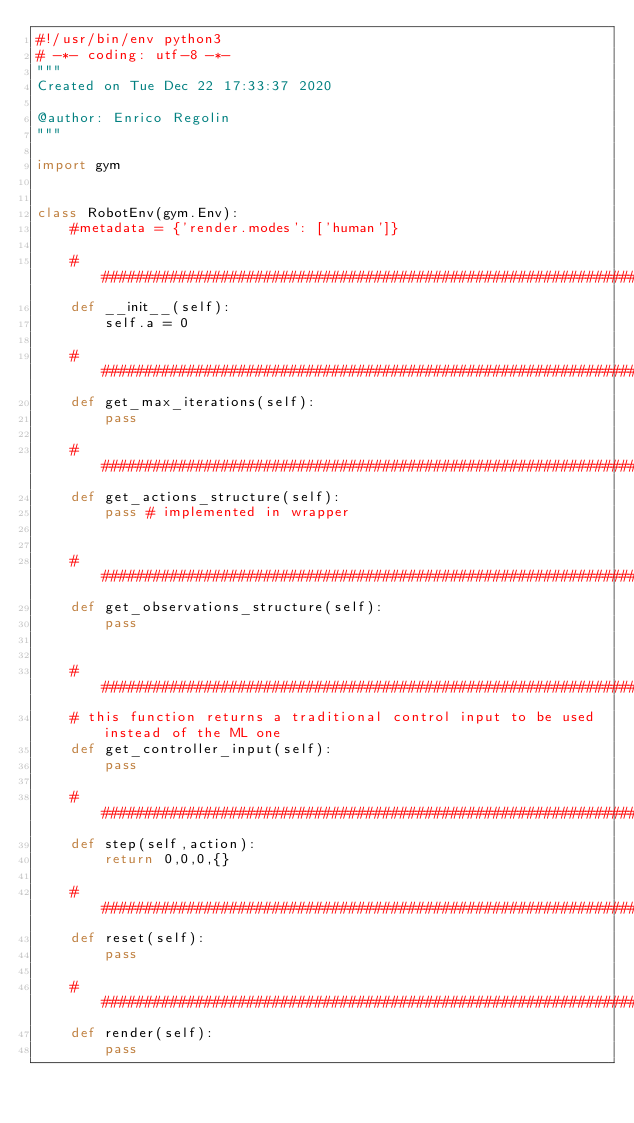Convert code to text. <code><loc_0><loc_0><loc_500><loc_500><_Python_>#!/usr/bin/env python3
# -*- coding: utf-8 -*-
"""
Created on Tue Dec 22 17:33:37 2020

@author: Enrico Regolin
"""

import gym


class RobotEnv(gym.Env):
    #metadata = {'render.modes': ['human']}

    #####################################################################################################
    def __init__(self):
        self.a = 0
        
    #####################################################################################################            
    def get_max_iterations(self):
        pass

    #####################################################################################################            
    def get_actions_structure(self):
        pass # implemented in wrapper

        
    #####################################################################################################            
    def get_observations_structure(self):
        pass


    #####################################################################################################            
    # this function returns a traditional control input to be used instead of the ML one
    def get_controller_input(self):
        pass

    #####################################################################################################            
    def step(self,action):
        return 0,0,0,{}
    
    #####################################################################################################
    def reset(self):
        pass
    
    #####################################################################################################    
    def render(self):
        pass</code> 